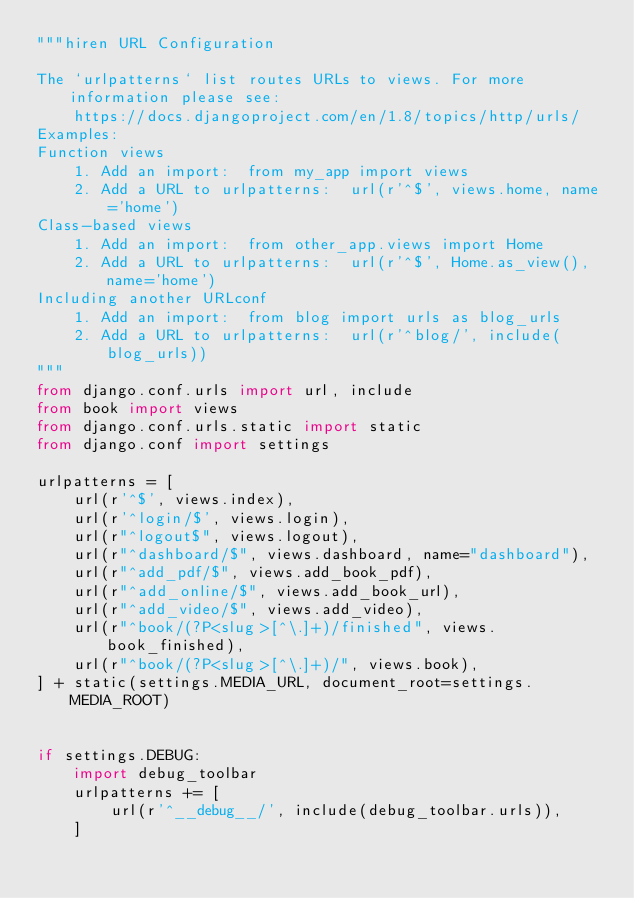<code> <loc_0><loc_0><loc_500><loc_500><_Python_>"""hiren URL Configuration

The `urlpatterns` list routes URLs to views. For more information please see:
    https://docs.djangoproject.com/en/1.8/topics/http/urls/
Examples:
Function views
    1. Add an import:  from my_app import views
    2. Add a URL to urlpatterns:  url(r'^$', views.home, name='home')
Class-based views
    1. Add an import:  from other_app.views import Home
    2. Add a URL to urlpatterns:  url(r'^$', Home.as_view(), name='home')
Including another URLconf
    1. Add an import:  from blog import urls as blog_urls
    2. Add a URL to urlpatterns:  url(r'^blog/', include(blog_urls))
"""
from django.conf.urls import url, include
from book import views
from django.conf.urls.static import static
from django.conf import settings

urlpatterns = [
    url(r'^$', views.index),
    url(r'^login/$', views.login),
    url(r"^logout$", views.logout),
    url(r"^dashboard/$", views.dashboard, name="dashboard"),
    url(r"^add_pdf/$", views.add_book_pdf),
    url(r"^add_online/$", views.add_book_url),
    url(r"^add_video/$", views.add_video),
    url(r"^book/(?P<slug>[^\.]+)/finished", views.book_finished),
    url(r"^book/(?P<slug>[^\.]+)/", views.book),
] + static(settings.MEDIA_URL, document_root=settings.MEDIA_ROOT)


if settings.DEBUG:
    import debug_toolbar
    urlpatterns += [
        url(r'^__debug__/', include(debug_toolbar.urls)),
    ]
</code> 